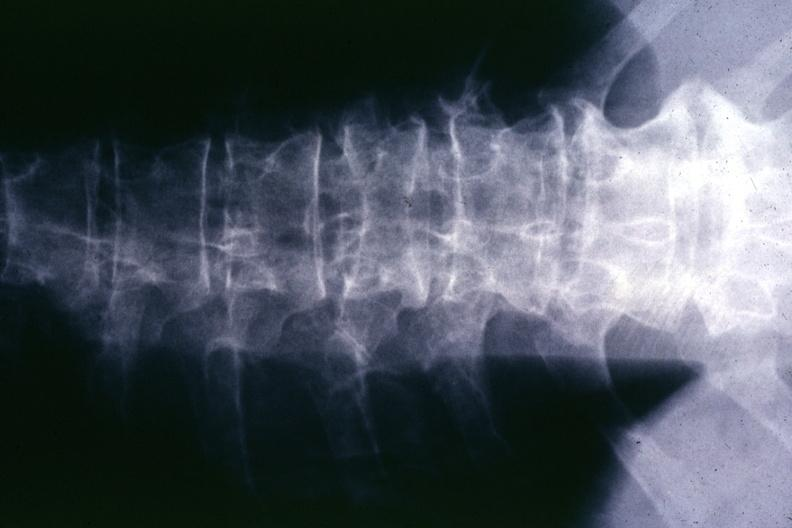what does this image show?
Answer the question using a single word or phrase. X-ray multiple punched out areas and compression fracture 